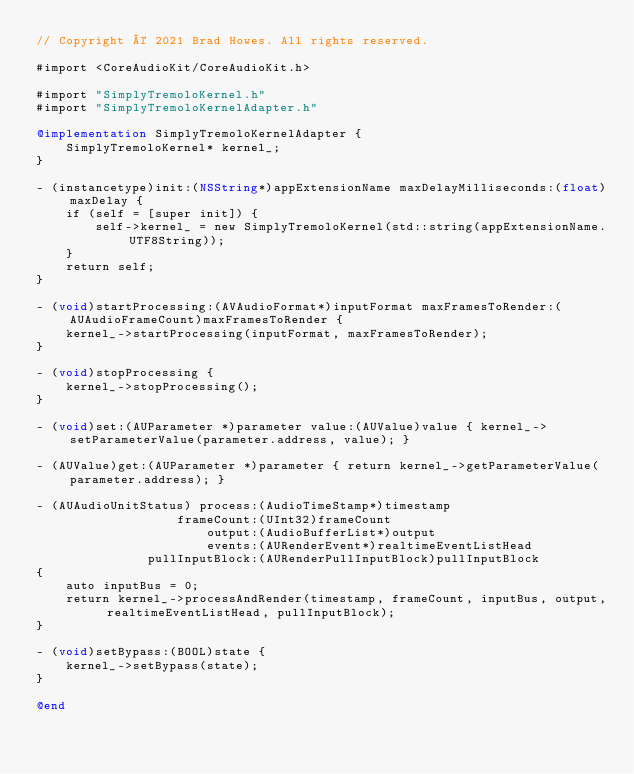Convert code to text. <code><loc_0><loc_0><loc_500><loc_500><_ObjectiveC_>// Copyright © 2021 Brad Howes. All rights reserved.

#import <CoreAudioKit/CoreAudioKit.h>

#import "SimplyTremoloKernel.h"
#import "SimplyTremoloKernelAdapter.h"

@implementation SimplyTremoloKernelAdapter {
    SimplyTremoloKernel* kernel_;
}

- (instancetype)init:(NSString*)appExtensionName maxDelayMilliseconds:(float)maxDelay {
    if (self = [super init]) {
        self->kernel_ = new SimplyTremoloKernel(std::string(appExtensionName.UTF8String));
    }
    return self;
}

- (void)startProcessing:(AVAudioFormat*)inputFormat maxFramesToRender:(AUAudioFrameCount)maxFramesToRender {
    kernel_->startProcessing(inputFormat, maxFramesToRender);
}

- (void)stopProcessing {
    kernel_->stopProcessing();
}

- (void)set:(AUParameter *)parameter value:(AUValue)value { kernel_->setParameterValue(parameter.address, value); }

- (AUValue)get:(AUParameter *)parameter { return kernel_->getParameterValue(parameter.address); }

- (AUAudioUnitStatus) process:(AudioTimeStamp*)timestamp
                   frameCount:(UInt32)frameCount
                       output:(AudioBufferList*)output
                       events:(AURenderEvent*)realtimeEventListHead
               pullInputBlock:(AURenderPullInputBlock)pullInputBlock
{
    auto inputBus = 0;
    return kernel_->processAndRender(timestamp, frameCount, inputBus, output, realtimeEventListHead, pullInputBlock);
}

- (void)setBypass:(BOOL)state {
    kernel_->setBypass(state);
}

@end
</code> 